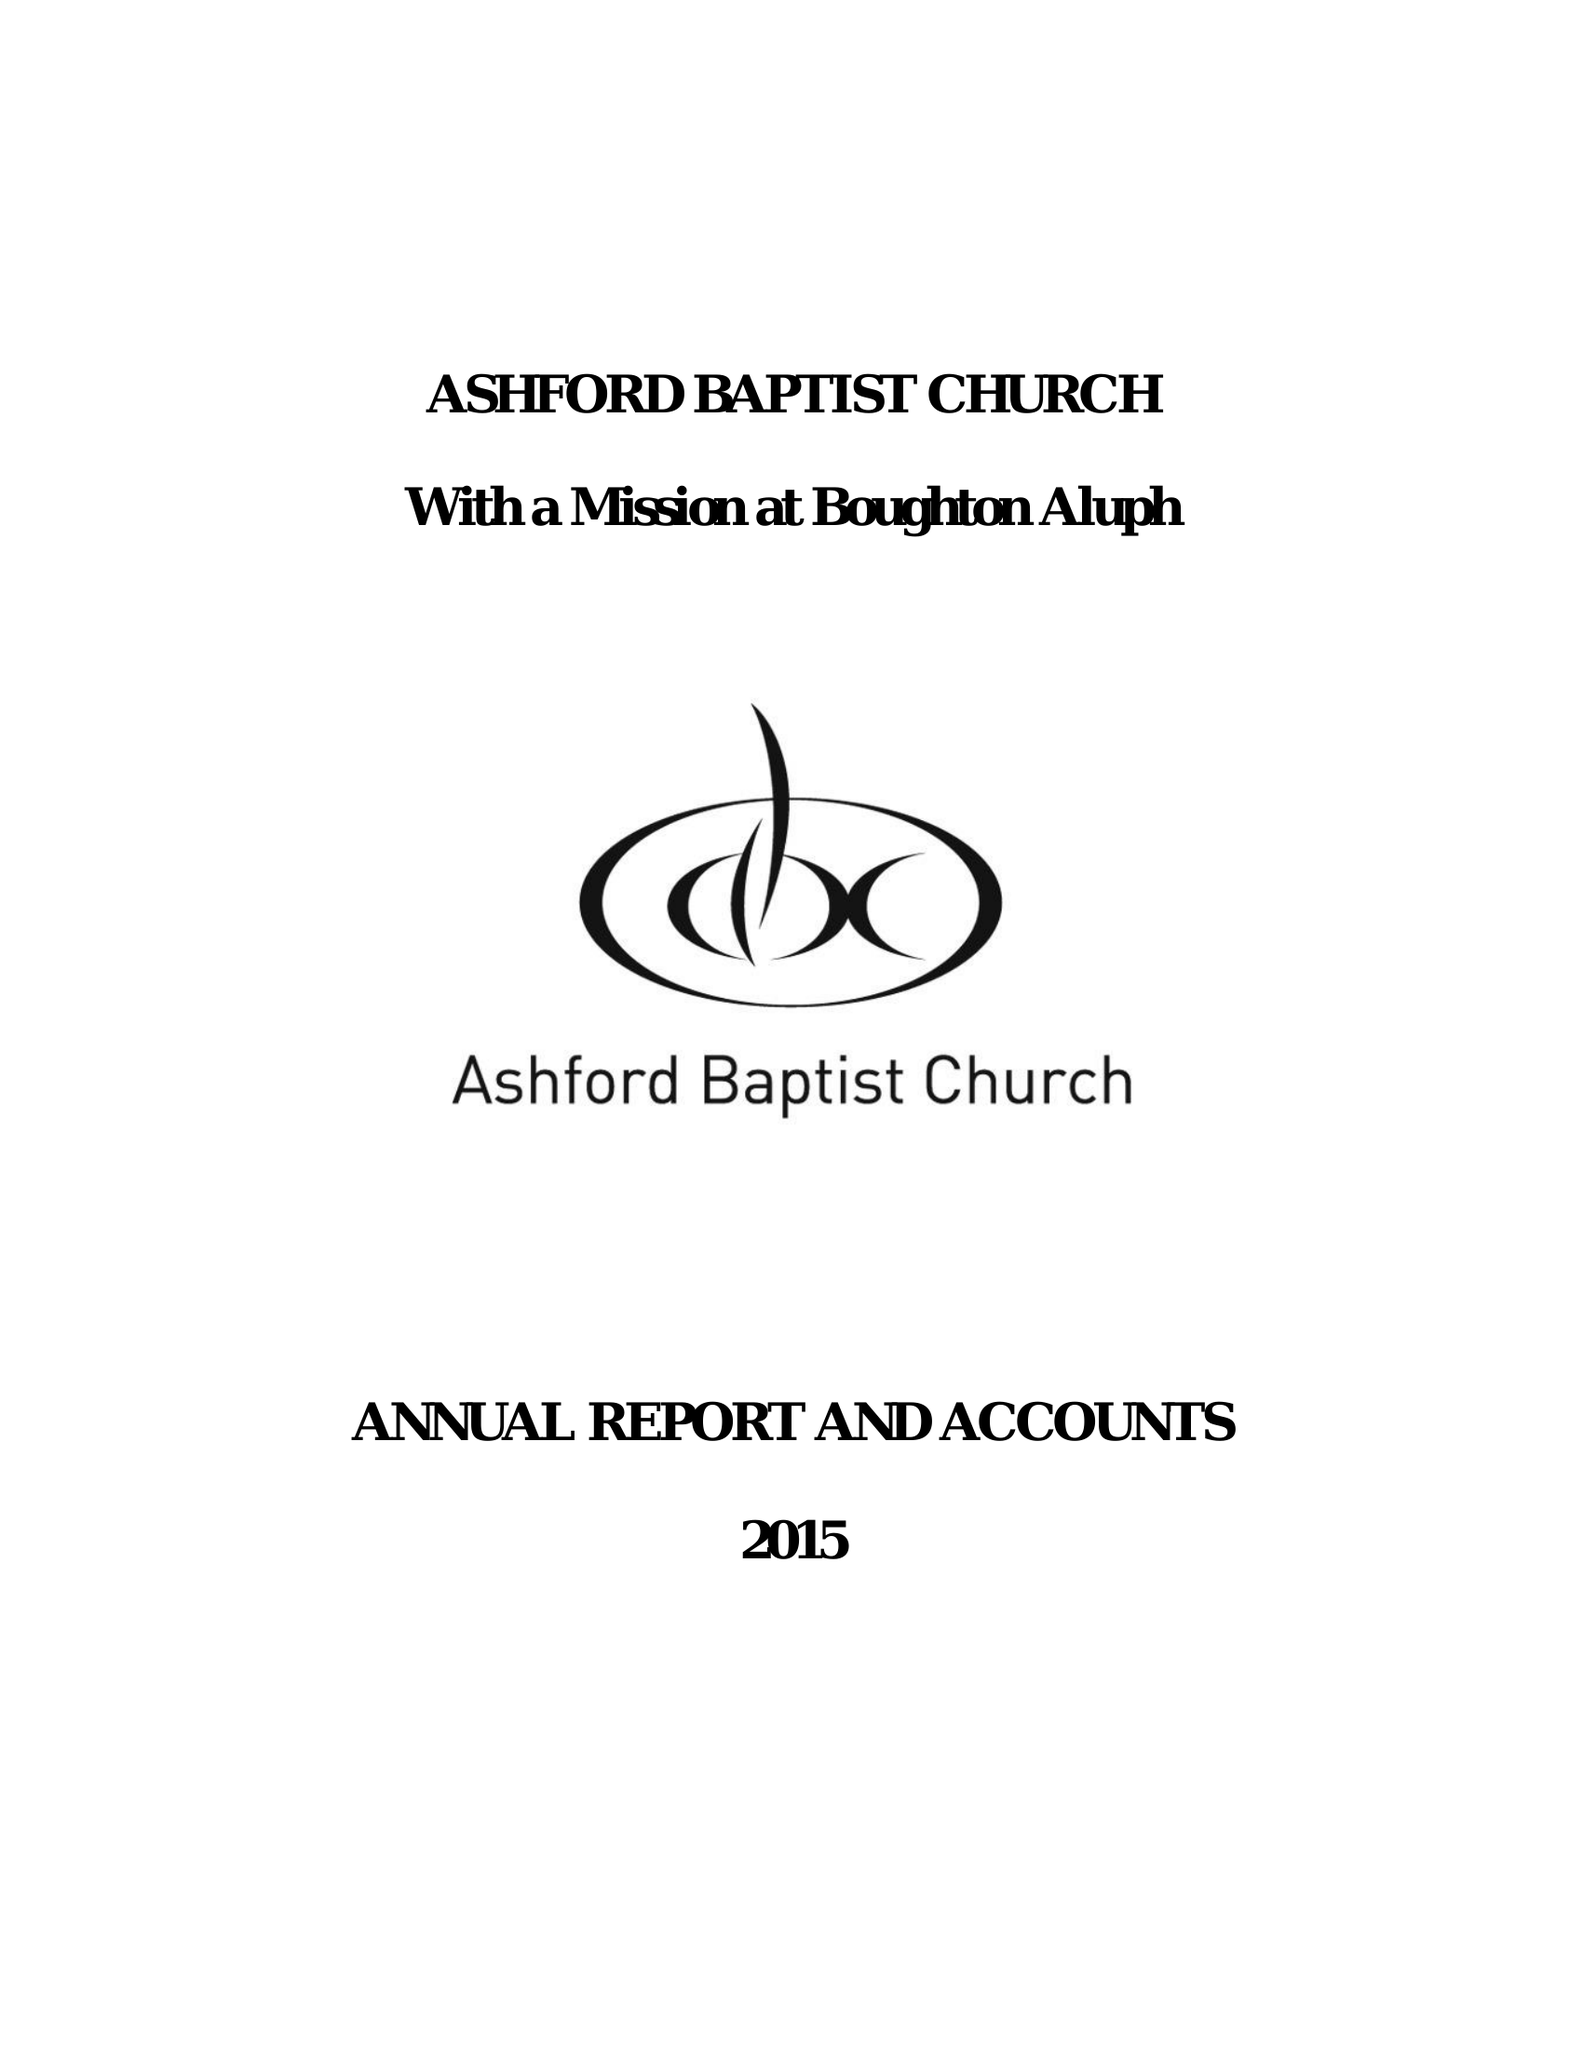What is the value for the address__post_town?
Answer the question using a single word or phrase. ASHFORD 